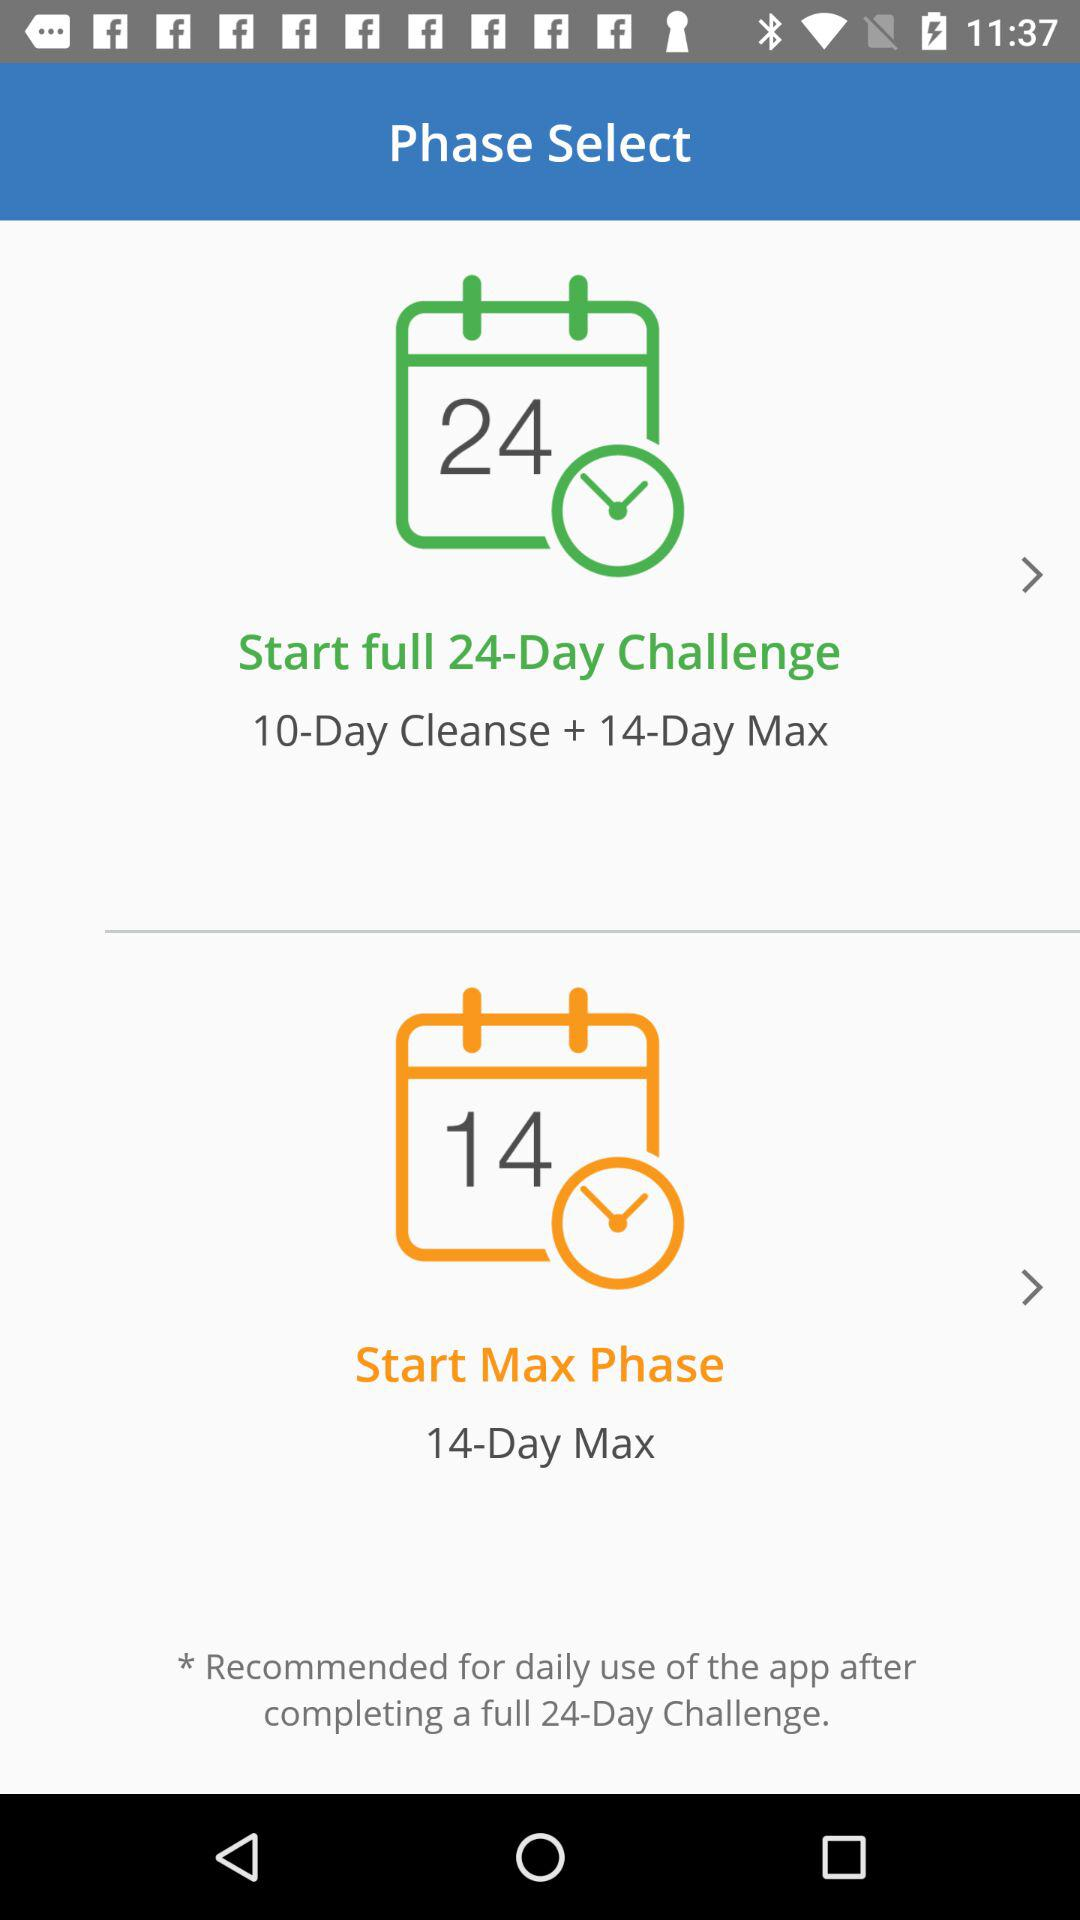How many days shorter is the 14-Day Max phase than the full 24-Day Challenge phase?
Answer the question using a single word or phrase. 10 